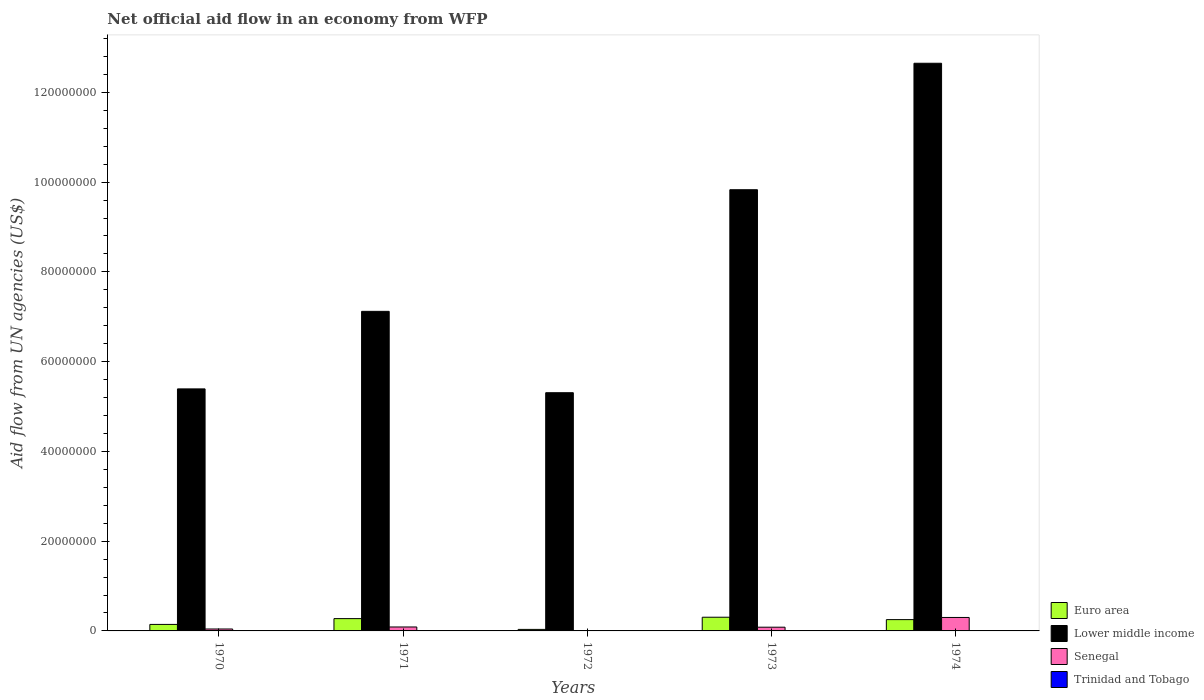Are the number of bars per tick equal to the number of legend labels?
Provide a succinct answer. No. How many bars are there on the 5th tick from the left?
Your response must be concise. 4. What is the label of the 1st group of bars from the left?
Provide a succinct answer. 1970. Across all years, what is the maximum net official aid flow in Senegal?
Keep it short and to the point. 3.00e+06. Across all years, what is the minimum net official aid flow in Trinidad and Tobago?
Ensure brevity in your answer.  3.00e+04. What is the total net official aid flow in Euro area in the graph?
Offer a terse response. 1.01e+07. What is the difference between the net official aid flow in Lower middle income in 1970 and that in 1974?
Keep it short and to the point. -7.26e+07. What is the difference between the net official aid flow in Trinidad and Tobago in 1970 and the net official aid flow in Lower middle income in 1971?
Provide a short and direct response. -7.11e+07. What is the average net official aid flow in Senegal per year?
Offer a terse response. 1.03e+06. In the year 1971, what is the difference between the net official aid flow in Euro area and net official aid flow in Senegal?
Your response must be concise. 1.86e+06. In how many years, is the net official aid flow in Euro area greater than 24000000 US$?
Make the answer very short. 0. What is the difference between the highest and the second highest net official aid flow in Trinidad and Tobago?
Make the answer very short. 0. Is the sum of the net official aid flow in Lower middle income in 1971 and 1974 greater than the maximum net official aid flow in Trinidad and Tobago across all years?
Your response must be concise. Yes. Is it the case that in every year, the sum of the net official aid flow in Senegal and net official aid flow in Euro area is greater than the net official aid flow in Lower middle income?
Provide a short and direct response. No. How many bars are there?
Offer a very short reply. 19. Are all the bars in the graph horizontal?
Offer a terse response. No. How many years are there in the graph?
Provide a succinct answer. 5. What is the difference between two consecutive major ticks on the Y-axis?
Provide a short and direct response. 2.00e+07. Does the graph contain grids?
Your answer should be compact. No. Where does the legend appear in the graph?
Offer a terse response. Bottom right. What is the title of the graph?
Offer a very short reply. Net official aid flow in an economy from WFP. What is the label or title of the Y-axis?
Offer a terse response. Aid flow from UN agencies (US$). What is the Aid flow from UN agencies (US$) of Euro area in 1970?
Give a very brief answer. 1.45e+06. What is the Aid flow from UN agencies (US$) of Lower middle income in 1970?
Make the answer very short. 5.39e+07. What is the Aid flow from UN agencies (US$) in Trinidad and Tobago in 1970?
Make the answer very short. 7.00e+04. What is the Aid flow from UN agencies (US$) in Euro area in 1971?
Your response must be concise. 2.74e+06. What is the Aid flow from UN agencies (US$) of Lower middle income in 1971?
Offer a terse response. 7.12e+07. What is the Aid flow from UN agencies (US$) of Senegal in 1971?
Offer a very short reply. 8.80e+05. What is the Aid flow from UN agencies (US$) of Lower middle income in 1972?
Keep it short and to the point. 5.31e+07. What is the Aid flow from UN agencies (US$) in Senegal in 1972?
Provide a succinct answer. 0. What is the Aid flow from UN agencies (US$) in Euro area in 1973?
Your answer should be compact. 3.05e+06. What is the Aid flow from UN agencies (US$) in Lower middle income in 1973?
Keep it short and to the point. 9.83e+07. What is the Aid flow from UN agencies (US$) of Senegal in 1973?
Ensure brevity in your answer.  8.30e+05. What is the Aid flow from UN agencies (US$) in Trinidad and Tobago in 1973?
Keep it short and to the point. 3.00e+04. What is the Aid flow from UN agencies (US$) of Euro area in 1974?
Your answer should be compact. 2.52e+06. What is the Aid flow from UN agencies (US$) of Lower middle income in 1974?
Make the answer very short. 1.26e+08. What is the Aid flow from UN agencies (US$) of Senegal in 1974?
Your answer should be very brief. 3.00e+06. Across all years, what is the maximum Aid flow from UN agencies (US$) in Euro area?
Offer a terse response. 3.05e+06. Across all years, what is the maximum Aid flow from UN agencies (US$) in Lower middle income?
Your answer should be compact. 1.26e+08. Across all years, what is the maximum Aid flow from UN agencies (US$) of Senegal?
Ensure brevity in your answer.  3.00e+06. Across all years, what is the maximum Aid flow from UN agencies (US$) in Trinidad and Tobago?
Your response must be concise. 7.00e+04. Across all years, what is the minimum Aid flow from UN agencies (US$) of Euro area?
Offer a very short reply. 3.40e+05. Across all years, what is the minimum Aid flow from UN agencies (US$) in Lower middle income?
Your response must be concise. 5.31e+07. What is the total Aid flow from UN agencies (US$) of Euro area in the graph?
Provide a short and direct response. 1.01e+07. What is the total Aid flow from UN agencies (US$) of Lower middle income in the graph?
Make the answer very short. 4.03e+08. What is the total Aid flow from UN agencies (US$) in Senegal in the graph?
Make the answer very short. 5.14e+06. What is the difference between the Aid flow from UN agencies (US$) of Euro area in 1970 and that in 1971?
Give a very brief answer. -1.29e+06. What is the difference between the Aid flow from UN agencies (US$) in Lower middle income in 1970 and that in 1971?
Make the answer very short. -1.73e+07. What is the difference between the Aid flow from UN agencies (US$) of Senegal in 1970 and that in 1971?
Your answer should be very brief. -4.50e+05. What is the difference between the Aid flow from UN agencies (US$) of Trinidad and Tobago in 1970 and that in 1971?
Offer a terse response. 0. What is the difference between the Aid flow from UN agencies (US$) of Euro area in 1970 and that in 1972?
Provide a succinct answer. 1.11e+06. What is the difference between the Aid flow from UN agencies (US$) of Lower middle income in 1970 and that in 1972?
Give a very brief answer. 8.50e+05. What is the difference between the Aid flow from UN agencies (US$) of Euro area in 1970 and that in 1973?
Offer a terse response. -1.60e+06. What is the difference between the Aid flow from UN agencies (US$) of Lower middle income in 1970 and that in 1973?
Your answer should be very brief. -4.44e+07. What is the difference between the Aid flow from UN agencies (US$) in Senegal in 1970 and that in 1973?
Offer a very short reply. -4.00e+05. What is the difference between the Aid flow from UN agencies (US$) of Euro area in 1970 and that in 1974?
Offer a very short reply. -1.07e+06. What is the difference between the Aid flow from UN agencies (US$) in Lower middle income in 1970 and that in 1974?
Provide a short and direct response. -7.26e+07. What is the difference between the Aid flow from UN agencies (US$) in Senegal in 1970 and that in 1974?
Your answer should be compact. -2.57e+06. What is the difference between the Aid flow from UN agencies (US$) of Trinidad and Tobago in 1970 and that in 1974?
Offer a very short reply. 3.00e+04. What is the difference between the Aid flow from UN agencies (US$) in Euro area in 1971 and that in 1972?
Provide a succinct answer. 2.40e+06. What is the difference between the Aid flow from UN agencies (US$) in Lower middle income in 1971 and that in 1972?
Offer a terse response. 1.81e+07. What is the difference between the Aid flow from UN agencies (US$) of Euro area in 1971 and that in 1973?
Provide a succinct answer. -3.10e+05. What is the difference between the Aid flow from UN agencies (US$) in Lower middle income in 1971 and that in 1973?
Ensure brevity in your answer.  -2.71e+07. What is the difference between the Aid flow from UN agencies (US$) in Lower middle income in 1971 and that in 1974?
Your response must be concise. -5.53e+07. What is the difference between the Aid flow from UN agencies (US$) in Senegal in 1971 and that in 1974?
Ensure brevity in your answer.  -2.12e+06. What is the difference between the Aid flow from UN agencies (US$) in Euro area in 1972 and that in 1973?
Your response must be concise. -2.71e+06. What is the difference between the Aid flow from UN agencies (US$) of Lower middle income in 1972 and that in 1973?
Your answer should be compact. -4.52e+07. What is the difference between the Aid flow from UN agencies (US$) in Trinidad and Tobago in 1972 and that in 1973?
Ensure brevity in your answer.  4.00e+04. What is the difference between the Aid flow from UN agencies (US$) in Euro area in 1972 and that in 1974?
Provide a succinct answer. -2.18e+06. What is the difference between the Aid flow from UN agencies (US$) in Lower middle income in 1972 and that in 1974?
Provide a short and direct response. -7.34e+07. What is the difference between the Aid flow from UN agencies (US$) of Trinidad and Tobago in 1972 and that in 1974?
Keep it short and to the point. 3.00e+04. What is the difference between the Aid flow from UN agencies (US$) in Euro area in 1973 and that in 1974?
Offer a very short reply. 5.30e+05. What is the difference between the Aid flow from UN agencies (US$) in Lower middle income in 1973 and that in 1974?
Your answer should be very brief. -2.82e+07. What is the difference between the Aid flow from UN agencies (US$) of Senegal in 1973 and that in 1974?
Ensure brevity in your answer.  -2.17e+06. What is the difference between the Aid flow from UN agencies (US$) in Trinidad and Tobago in 1973 and that in 1974?
Offer a terse response. -10000. What is the difference between the Aid flow from UN agencies (US$) of Euro area in 1970 and the Aid flow from UN agencies (US$) of Lower middle income in 1971?
Provide a succinct answer. -6.98e+07. What is the difference between the Aid flow from UN agencies (US$) of Euro area in 1970 and the Aid flow from UN agencies (US$) of Senegal in 1971?
Offer a very short reply. 5.70e+05. What is the difference between the Aid flow from UN agencies (US$) in Euro area in 1970 and the Aid flow from UN agencies (US$) in Trinidad and Tobago in 1971?
Offer a terse response. 1.38e+06. What is the difference between the Aid flow from UN agencies (US$) of Lower middle income in 1970 and the Aid flow from UN agencies (US$) of Senegal in 1971?
Provide a succinct answer. 5.30e+07. What is the difference between the Aid flow from UN agencies (US$) in Lower middle income in 1970 and the Aid flow from UN agencies (US$) in Trinidad and Tobago in 1971?
Your answer should be very brief. 5.39e+07. What is the difference between the Aid flow from UN agencies (US$) in Senegal in 1970 and the Aid flow from UN agencies (US$) in Trinidad and Tobago in 1971?
Offer a very short reply. 3.60e+05. What is the difference between the Aid flow from UN agencies (US$) in Euro area in 1970 and the Aid flow from UN agencies (US$) in Lower middle income in 1972?
Give a very brief answer. -5.16e+07. What is the difference between the Aid flow from UN agencies (US$) in Euro area in 1970 and the Aid flow from UN agencies (US$) in Trinidad and Tobago in 1972?
Provide a succinct answer. 1.38e+06. What is the difference between the Aid flow from UN agencies (US$) in Lower middle income in 1970 and the Aid flow from UN agencies (US$) in Trinidad and Tobago in 1972?
Offer a terse response. 5.39e+07. What is the difference between the Aid flow from UN agencies (US$) of Euro area in 1970 and the Aid flow from UN agencies (US$) of Lower middle income in 1973?
Make the answer very short. -9.69e+07. What is the difference between the Aid flow from UN agencies (US$) in Euro area in 1970 and the Aid flow from UN agencies (US$) in Senegal in 1973?
Give a very brief answer. 6.20e+05. What is the difference between the Aid flow from UN agencies (US$) in Euro area in 1970 and the Aid flow from UN agencies (US$) in Trinidad and Tobago in 1973?
Offer a very short reply. 1.42e+06. What is the difference between the Aid flow from UN agencies (US$) in Lower middle income in 1970 and the Aid flow from UN agencies (US$) in Senegal in 1973?
Offer a very short reply. 5.31e+07. What is the difference between the Aid flow from UN agencies (US$) of Lower middle income in 1970 and the Aid flow from UN agencies (US$) of Trinidad and Tobago in 1973?
Keep it short and to the point. 5.39e+07. What is the difference between the Aid flow from UN agencies (US$) of Euro area in 1970 and the Aid flow from UN agencies (US$) of Lower middle income in 1974?
Offer a very short reply. -1.25e+08. What is the difference between the Aid flow from UN agencies (US$) of Euro area in 1970 and the Aid flow from UN agencies (US$) of Senegal in 1974?
Provide a short and direct response. -1.55e+06. What is the difference between the Aid flow from UN agencies (US$) in Euro area in 1970 and the Aid flow from UN agencies (US$) in Trinidad and Tobago in 1974?
Your answer should be very brief. 1.41e+06. What is the difference between the Aid flow from UN agencies (US$) in Lower middle income in 1970 and the Aid flow from UN agencies (US$) in Senegal in 1974?
Your response must be concise. 5.09e+07. What is the difference between the Aid flow from UN agencies (US$) of Lower middle income in 1970 and the Aid flow from UN agencies (US$) of Trinidad and Tobago in 1974?
Your answer should be compact. 5.39e+07. What is the difference between the Aid flow from UN agencies (US$) in Senegal in 1970 and the Aid flow from UN agencies (US$) in Trinidad and Tobago in 1974?
Ensure brevity in your answer.  3.90e+05. What is the difference between the Aid flow from UN agencies (US$) in Euro area in 1971 and the Aid flow from UN agencies (US$) in Lower middle income in 1972?
Keep it short and to the point. -5.03e+07. What is the difference between the Aid flow from UN agencies (US$) of Euro area in 1971 and the Aid flow from UN agencies (US$) of Trinidad and Tobago in 1972?
Your response must be concise. 2.67e+06. What is the difference between the Aid flow from UN agencies (US$) of Lower middle income in 1971 and the Aid flow from UN agencies (US$) of Trinidad and Tobago in 1972?
Ensure brevity in your answer.  7.11e+07. What is the difference between the Aid flow from UN agencies (US$) in Senegal in 1971 and the Aid flow from UN agencies (US$) in Trinidad and Tobago in 1972?
Provide a succinct answer. 8.10e+05. What is the difference between the Aid flow from UN agencies (US$) of Euro area in 1971 and the Aid flow from UN agencies (US$) of Lower middle income in 1973?
Give a very brief answer. -9.56e+07. What is the difference between the Aid flow from UN agencies (US$) in Euro area in 1971 and the Aid flow from UN agencies (US$) in Senegal in 1973?
Offer a very short reply. 1.91e+06. What is the difference between the Aid flow from UN agencies (US$) in Euro area in 1971 and the Aid flow from UN agencies (US$) in Trinidad and Tobago in 1973?
Your answer should be very brief. 2.71e+06. What is the difference between the Aid flow from UN agencies (US$) of Lower middle income in 1971 and the Aid flow from UN agencies (US$) of Senegal in 1973?
Give a very brief answer. 7.04e+07. What is the difference between the Aid flow from UN agencies (US$) in Lower middle income in 1971 and the Aid flow from UN agencies (US$) in Trinidad and Tobago in 1973?
Provide a succinct answer. 7.12e+07. What is the difference between the Aid flow from UN agencies (US$) in Senegal in 1971 and the Aid flow from UN agencies (US$) in Trinidad and Tobago in 1973?
Offer a terse response. 8.50e+05. What is the difference between the Aid flow from UN agencies (US$) of Euro area in 1971 and the Aid flow from UN agencies (US$) of Lower middle income in 1974?
Offer a terse response. -1.24e+08. What is the difference between the Aid flow from UN agencies (US$) of Euro area in 1971 and the Aid flow from UN agencies (US$) of Senegal in 1974?
Your response must be concise. -2.60e+05. What is the difference between the Aid flow from UN agencies (US$) of Euro area in 1971 and the Aid flow from UN agencies (US$) of Trinidad and Tobago in 1974?
Make the answer very short. 2.70e+06. What is the difference between the Aid flow from UN agencies (US$) of Lower middle income in 1971 and the Aid flow from UN agencies (US$) of Senegal in 1974?
Provide a short and direct response. 6.82e+07. What is the difference between the Aid flow from UN agencies (US$) in Lower middle income in 1971 and the Aid flow from UN agencies (US$) in Trinidad and Tobago in 1974?
Provide a short and direct response. 7.12e+07. What is the difference between the Aid flow from UN agencies (US$) in Senegal in 1971 and the Aid flow from UN agencies (US$) in Trinidad and Tobago in 1974?
Your response must be concise. 8.40e+05. What is the difference between the Aid flow from UN agencies (US$) of Euro area in 1972 and the Aid flow from UN agencies (US$) of Lower middle income in 1973?
Offer a very short reply. -9.80e+07. What is the difference between the Aid flow from UN agencies (US$) of Euro area in 1972 and the Aid flow from UN agencies (US$) of Senegal in 1973?
Your answer should be compact. -4.90e+05. What is the difference between the Aid flow from UN agencies (US$) of Lower middle income in 1972 and the Aid flow from UN agencies (US$) of Senegal in 1973?
Offer a very short reply. 5.22e+07. What is the difference between the Aid flow from UN agencies (US$) in Lower middle income in 1972 and the Aid flow from UN agencies (US$) in Trinidad and Tobago in 1973?
Your response must be concise. 5.30e+07. What is the difference between the Aid flow from UN agencies (US$) of Euro area in 1972 and the Aid flow from UN agencies (US$) of Lower middle income in 1974?
Provide a succinct answer. -1.26e+08. What is the difference between the Aid flow from UN agencies (US$) in Euro area in 1972 and the Aid flow from UN agencies (US$) in Senegal in 1974?
Your answer should be very brief. -2.66e+06. What is the difference between the Aid flow from UN agencies (US$) of Euro area in 1972 and the Aid flow from UN agencies (US$) of Trinidad and Tobago in 1974?
Ensure brevity in your answer.  3.00e+05. What is the difference between the Aid flow from UN agencies (US$) of Lower middle income in 1972 and the Aid flow from UN agencies (US$) of Senegal in 1974?
Offer a terse response. 5.01e+07. What is the difference between the Aid flow from UN agencies (US$) in Lower middle income in 1972 and the Aid flow from UN agencies (US$) in Trinidad and Tobago in 1974?
Your response must be concise. 5.30e+07. What is the difference between the Aid flow from UN agencies (US$) in Euro area in 1973 and the Aid flow from UN agencies (US$) in Lower middle income in 1974?
Your answer should be very brief. -1.23e+08. What is the difference between the Aid flow from UN agencies (US$) of Euro area in 1973 and the Aid flow from UN agencies (US$) of Senegal in 1974?
Provide a succinct answer. 5.00e+04. What is the difference between the Aid flow from UN agencies (US$) of Euro area in 1973 and the Aid flow from UN agencies (US$) of Trinidad and Tobago in 1974?
Ensure brevity in your answer.  3.01e+06. What is the difference between the Aid flow from UN agencies (US$) of Lower middle income in 1973 and the Aid flow from UN agencies (US$) of Senegal in 1974?
Keep it short and to the point. 9.53e+07. What is the difference between the Aid flow from UN agencies (US$) in Lower middle income in 1973 and the Aid flow from UN agencies (US$) in Trinidad and Tobago in 1974?
Ensure brevity in your answer.  9.83e+07. What is the difference between the Aid flow from UN agencies (US$) in Senegal in 1973 and the Aid flow from UN agencies (US$) in Trinidad and Tobago in 1974?
Ensure brevity in your answer.  7.90e+05. What is the average Aid flow from UN agencies (US$) in Euro area per year?
Make the answer very short. 2.02e+06. What is the average Aid flow from UN agencies (US$) of Lower middle income per year?
Make the answer very short. 8.06e+07. What is the average Aid flow from UN agencies (US$) of Senegal per year?
Offer a terse response. 1.03e+06. What is the average Aid flow from UN agencies (US$) in Trinidad and Tobago per year?
Ensure brevity in your answer.  5.60e+04. In the year 1970, what is the difference between the Aid flow from UN agencies (US$) of Euro area and Aid flow from UN agencies (US$) of Lower middle income?
Your response must be concise. -5.25e+07. In the year 1970, what is the difference between the Aid flow from UN agencies (US$) of Euro area and Aid flow from UN agencies (US$) of Senegal?
Provide a short and direct response. 1.02e+06. In the year 1970, what is the difference between the Aid flow from UN agencies (US$) of Euro area and Aid flow from UN agencies (US$) of Trinidad and Tobago?
Ensure brevity in your answer.  1.38e+06. In the year 1970, what is the difference between the Aid flow from UN agencies (US$) in Lower middle income and Aid flow from UN agencies (US$) in Senegal?
Offer a terse response. 5.35e+07. In the year 1970, what is the difference between the Aid flow from UN agencies (US$) of Lower middle income and Aid flow from UN agencies (US$) of Trinidad and Tobago?
Your response must be concise. 5.39e+07. In the year 1970, what is the difference between the Aid flow from UN agencies (US$) of Senegal and Aid flow from UN agencies (US$) of Trinidad and Tobago?
Give a very brief answer. 3.60e+05. In the year 1971, what is the difference between the Aid flow from UN agencies (US$) of Euro area and Aid flow from UN agencies (US$) of Lower middle income?
Offer a terse response. -6.85e+07. In the year 1971, what is the difference between the Aid flow from UN agencies (US$) in Euro area and Aid flow from UN agencies (US$) in Senegal?
Offer a terse response. 1.86e+06. In the year 1971, what is the difference between the Aid flow from UN agencies (US$) in Euro area and Aid flow from UN agencies (US$) in Trinidad and Tobago?
Make the answer very short. 2.67e+06. In the year 1971, what is the difference between the Aid flow from UN agencies (US$) of Lower middle income and Aid flow from UN agencies (US$) of Senegal?
Your response must be concise. 7.03e+07. In the year 1971, what is the difference between the Aid flow from UN agencies (US$) in Lower middle income and Aid flow from UN agencies (US$) in Trinidad and Tobago?
Offer a terse response. 7.11e+07. In the year 1971, what is the difference between the Aid flow from UN agencies (US$) of Senegal and Aid flow from UN agencies (US$) of Trinidad and Tobago?
Make the answer very short. 8.10e+05. In the year 1972, what is the difference between the Aid flow from UN agencies (US$) in Euro area and Aid flow from UN agencies (US$) in Lower middle income?
Your answer should be compact. -5.27e+07. In the year 1972, what is the difference between the Aid flow from UN agencies (US$) in Euro area and Aid flow from UN agencies (US$) in Trinidad and Tobago?
Your response must be concise. 2.70e+05. In the year 1972, what is the difference between the Aid flow from UN agencies (US$) of Lower middle income and Aid flow from UN agencies (US$) of Trinidad and Tobago?
Make the answer very short. 5.30e+07. In the year 1973, what is the difference between the Aid flow from UN agencies (US$) in Euro area and Aid flow from UN agencies (US$) in Lower middle income?
Make the answer very short. -9.53e+07. In the year 1973, what is the difference between the Aid flow from UN agencies (US$) of Euro area and Aid flow from UN agencies (US$) of Senegal?
Offer a very short reply. 2.22e+06. In the year 1973, what is the difference between the Aid flow from UN agencies (US$) in Euro area and Aid flow from UN agencies (US$) in Trinidad and Tobago?
Give a very brief answer. 3.02e+06. In the year 1973, what is the difference between the Aid flow from UN agencies (US$) in Lower middle income and Aid flow from UN agencies (US$) in Senegal?
Offer a very short reply. 9.75e+07. In the year 1973, what is the difference between the Aid flow from UN agencies (US$) of Lower middle income and Aid flow from UN agencies (US$) of Trinidad and Tobago?
Give a very brief answer. 9.83e+07. In the year 1973, what is the difference between the Aid flow from UN agencies (US$) of Senegal and Aid flow from UN agencies (US$) of Trinidad and Tobago?
Provide a short and direct response. 8.00e+05. In the year 1974, what is the difference between the Aid flow from UN agencies (US$) in Euro area and Aid flow from UN agencies (US$) in Lower middle income?
Your answer should be compact. -1.24e+08. In the year 1974, what is the difference between the Aid flow from UN agencies (US$) of Euro area and Aid flow from UN agencies (US$) of Senegal?
Keep it short and to the point. -4.80e+05. In the year 1974, what is the difference between the Aid flow from UN agencies (US$) of Euro area and Aid flow from UN agencies (US$) of Trinidad and Tobago?
Make the answer very short. 2.48e+06. In the year 1974, what is the difference between the Aid flow from UN agencies (US$) of Lower middle income and Aid flow from UN agencies (US$) of Senegal?
Provide a short and direct response. 1.23e+08. In the year 1974, what is the difference between the Aid flow from UN agencies (US$) of Lower middle income and Aid flow from UN agencies (US$) of Trinidad and Tobago?
Your answer should be very brief. 1.26e+08. In the year 1974, what is the difference between the Aid flow from UN agencies (US$) in Senegal and Aid flow from UN agencies (US$) in Trinidad and Tobago?
Your answer should be very brief. 2.96e+06. What is the ratio of the Aid flow from UN agencies (US$) of Euro area in 1970 to that in 1971?
Provide a succinct answer. 0.53. What is the ratio of the Aid flow from UN agencies (US$) in Lower middle income in 1970 to that in 1971?
Ensure brevity in your answer.  0.76. What is the ratio of the Aid flow from UN agencies (US$) in Senegal in 1970 to that in 1971?
Ensure brevity in your answer.  0.49. What is the ratio of the Aid flow from UN agencies (US$) of Trinidad and Tobago in 1970 to that in 1971?
Offer a terse response. 1. What is the ratio of the Aid flow from UN agencies (US$) in Euro area in 1970 to that in 1972?
Give a very brief answer. 4.26. What is the ratio of the Aid flow from UN agencies (US$) in Lower middle income in 1970 to that in 1972?
Your answer should be compact. 1.02. What is the ratio of the Aid flow from UN agencies (US$) in Trinidad and Tobago in 1970 to that in 1972?
Provide a short and direct response. 1. What is the ratio of the Aid flow from UN agencies (US$) in Euro area in 1970 to that in 1973?
Your answer should be compact. 0.48. What is the ratio of the Aid flow from UN agencies (US$) of Lower middle income in 1970 to that in 1973?
Your answer should be very brief. 0.55. What is the ratio of the Aid flow from UN agencies (US$) of Senegal in 1970 to that in 1973?
Make the answer very short. 0.52. What is the ratio of the Aid flow from UN agencies (US$) of Trinidad and Tobago in 1970 to that in 1973?
Provide a succinct answer. 2.33. What is the ratio of the Aid flow from UN agencies (US$) in Euro area in 1970 to that in 1974?
Make the answer very short. 0.58. What is the ratio of the Aid flow from UN agencies (US$) in Lower middle income in 1970 to that in 1974?
Offer a terse response. 0.43. What is the ratio of the Aid flow from UN agencies (US$) of Senegal in 1970 to that in 1974?
Provide a short and direct response. 0.14. What is the ratio of the Aid flow from UN agencies (US$) in Trinidad and Tobago in 1970 to that in 1974?
Keep it short and to the point. 1.75. What is the ratio of the Aid flow from UN agencies (US$) in Euro area in 1971 to that in 1972?
Provide a succinct answer. 8.06. What is the ratio of the Aid flow from UN agencies (US$) of Lower middle income in 1971 to that in 1972?
Your answer should be compact. 1.34. What is the ratio of the Aid flow from UN agencies (US$) in Trinidad and Tobago in 1971 to that in 1972?
Keep it short and to the point. 1. What is the ratio of the Aid flow from UN agencies (US$) in Euro area in 1971 to that in 1973?
Provide a succinct answer. 0.9. What is the ratio of the Aid flow from UN agencies (US$) in Lower middle income in 1971 to that in 1973?
Your answer should be very brief. 0.72. What is the ratio of the Aid flow from UN agencies (US$) of Senegal in 1971 to that in 1973?
Your answer should be very brief. 1.06. What is the ratio of the Aid flow from UN agencies (US$) in Trinidad and Tobago in 1971 to that in 1973?
Your answer should be very brief. 2.33. What is the ratio of the Aid flow from UN agencies (US$) in Euro area in 1971 to that in 1974?
Make the answer very short. 1.09. What is the ratio of the Aid flow from UN agencies (US$) in Lower middle income in 1971 to that in 1974?
Offer a very short reply. 0.56. What is the ratio of the Aid flow from UN agencies (US$) in Senegal in 1971 to that in 1974?
Offer a very short reply. 0.29. What is the ratio of the Aid flow from UN agencies (US$) in Euro area in 1972 to that in 1973?
Ensure brevity in your answer.  0.11. What is the ratio of the Aid flow from UN agencies (US$) in Lower middle income in 1972 to that in 1973?
Your answer should be very brief. 0.54. What is the ratio of the Aid flow from UN agencies (US$) in Trinidad and Tobago in 1972 to that in 1973?
Provide a succinct answer. 2.33. What is the ratio of the Aid flow from UN agencies (US$) in Euro area in 1972 to that in 1974?
Provide a short and direct response. 0.13. What is the ratio of the Aid flow from UN agencies (US$) of Lower middle income in 1972 to that in 1974?
Offer a terse response. 0.42. What is the ratio of the Aid flow from UN agencies (US$) of Trinidad and Tobago in 1972 to that in 1974?
Your answer should be compact. 1.75. What is the ratio of the Aid flow from UN agencies (US$) in Euro area in 1973 to that in 1974?
Give a very brief answer. 1.21. What is the ratio of the Aid flow from UN agencies (US$) in Lower middle income in 1973 to that in 1974?
Your answer should be very brief. 0.78. What is the ratio of the Aid flow from UN agencies (US$) of Senegal in 1973 to that in 1974?
Your response must be concise. 0.28. What is the ratio of the Aid flow from UN agencies (US$) of Trinidad and Tobago in 1973 to that in 1974?
Make the answer very short. 0.75. What is the difference between the highest and the second highest Aid flow from UN agencies (US$) in Euro area?
Give a very brief answer. 3.10e+05. What is the difference between the highest and the second highest Aid flow from UN agencies (US$) in Lower middle income?
Your answer should be very brief. 2.82e+07. What is the difference between the highest and the second highest Aid flow from UN agencies (US$) of Senegal?
Keep it short and to the point. 2.12e+06. What is the difference between the highest and the lowest Aid flow from UN agencies (US$) in Euro area?
Offer a terse response. 2.71e+06. What is the difference between the highest and the lowest Aid flow from UN agencies (US$) of Lower middle income?
Your answer should be very brief. 7.34e+07. What is the difference between the highest and the lowest Aid flow from UN agencies (US$) in Trinidad and Tobago?
Your answer should be very brief. 4.00e+04. 